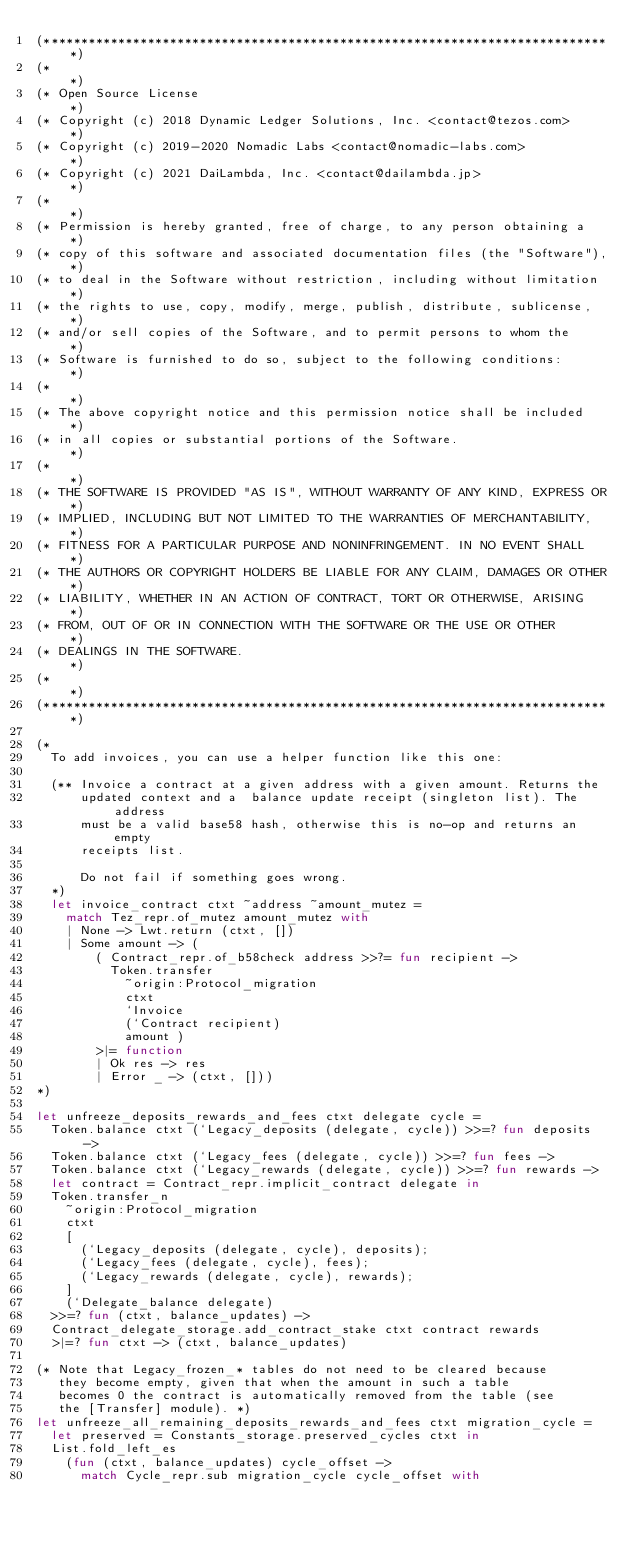Convert code to text. <code><loc_0><loc_0><loc_500><loc_500><_OCaml_>(*****************************************************************************)
(*                                                                           *)
(* Open Source License                                                       *)
(* Copyright (c) 2018 Dynamic Ledger Solutions, Inc. <contact@tezos.com>     *)
(* Copyright (c) 2019-2020 Nomadic Labs <contact@nomadic-labs.com>           *)
(* Copyright (c) 2021 DaiLambda, Inc. <contact@dailambda.jp>                 *)
(*                                                                           *)
(* Permission is hereby granted, free of charge, to any person obtaining a   *)
(* copy of this software and associated documentation files (the "Software"),*)
(* to deal in the Software without restriction, including without limitation *)
(* the rights to use, copy, modify, merge, publish, distribute, sublicense,  *)
(* and/or sell copies of the Software, and to permit persons to whom the     *)
(* Software is furnished to do so, subject to the following conditions:      *)
(*                                                                           *)
(* The above copyright notice and this permission notice shall be included   *)
(* in all copies or substantial portions of the Software.                    *)
(*                                                                           *)
(* THE SOFTWARE IS PROVIDED "AS IS", WITHOUT WARRANTY OF ANY KIND, EXPRESS OR*)
(* IMPLIED, INCLUDING BUT NOT LIMITED TO THE WARRANTIES OF MERCHANTABILITY,  *)
(* FITNESS FOR A PARTICULAR PURPOSE AND NONINFRINGEMENT. IN NO EVENT SHALL   *)
(* THE AUTHORS OR COPYRIGHT HOLDERS BE LIABLE FOR ANY CLAIM, DAMAGES OR OTHER*)
(* LIABILITY, WHETHER IN AN ACTION OF CONTRACT, TORT OR OTHERWISE, ARISING   *)
(* FROM, OUT OF OR IN CONNECTION WITH THE SOFTWARE OR THE USE OR OTHER       *)
(* DEALINGS IN THE SOFTWARE.                                                 *)
(*                                                                           *)
(*****************************************************************************)

(*
  To add invoices, you can use a helper function like this one:

  (** Invoice a contract at a given address with a given amount. Returns the
      updated context and a  balance update receipt (singleton list). The address
      must be a valid base58 hash, otherwise this is no-op and returns an empty
      receipts list.

      Do not fail if something goes wrong.
  *)
  let invoice_contract ctxt ~address ~amount_mutez =
    match Tez_repr.of_mutez amount_mutez with
    | None -> Lwt.return (ctxt, [])
    | Some amount -> (
        ( Contract_repr.of_b58check address >>?= fun recipient ->
          Token.transfer
            ~origin:Protocol_migration
            ctxt
            `Invoice
            (`Contract recipient)
            amount )
        >|= function
        | Ok res -> res
        | Error _ -> (ctxt, []))
*)

let unfreeze_deposits_rewards_and_fees ctxt delegate cycle =
  Token.balance ctxt (`Legacy_deposits (delegate, cycle)) >>=? fun deposits ->
  Token.balance ctxt (`Legacy_fees (delegate, cycle)) >>=? fun fees ->
  Token.balance ctxt (`Legacy_rewards (delegate, cycle)) >>=? fun rewards ->
  let contract = Contract_repr.implicit_contract delegate in
  Token.transfer_n
    ~origin:Protocol_migration
    ctxt
    [
      (`Legacy_deposits (delegate, cycle), deposits);
      (`Legacy_fees (delegate, cycle), fees);
      (`Legacy_rewards (delegate, cycle), rewards);
    ]
    (`Delegate_balance delegate)
  >>=? fun (ctxt, balance_updates) ->
  Contract_delegate_storage.add_contract_stake ctxt contract rewards
  >|=? fun ctxt -> (ctxt, balance_updates)

(* Note that Legacy_frozen_* tables do not need to be cleared because
   they become empty, given that when the amount in such a table
   becomes 0 the contract is automatically removed from the table (see
   the [Transfer] module). *)
let unfreeze_all_remaining_deposits_rewards_and_fees ctxt migration_cycle =
  let preserved = Constants_storage.preserved_cycles ctxt in
  List.fold_left_es
    (fun (ctxt, balance_updates) cycle_offset ->
      match Cycle_repr.sub migration_cycle cycle_offset with</code> 